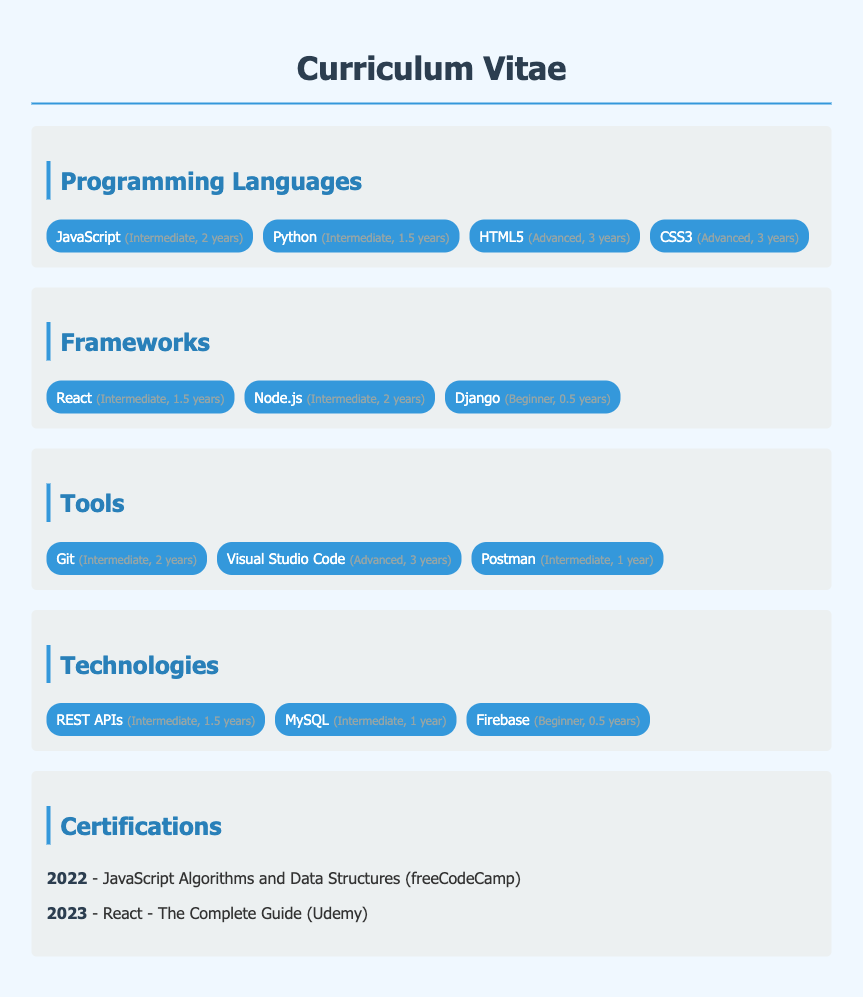what is the proficiency level of JavaScript? The proficiency level of JavaScript is listed as Intermediate with 2 years of experience.
Answer: Intermediate, 2 years how many programming languages are listed in the document? The document lists a total of four programming languages under the Programming Languages section.
Answer: 4 which framework has the highest proficiency level? The document does not mention a framework with a proficiency level higher than Intermediate; both React and Node.js have this level.
Answer: Intermediate when was the React certification obtained? The React certification is obtained in the year 2023 according to the Certifications section.
Answer: 2023 what is the total years of experience with tools mentioned? The tools listed indicate a total of 6 years of experience when adding up the individual experience years (3 + 2 + 1).
Answer: 6 years which technology has the least experience? The technology with the least experience mentioned is Firebase, with only 0.5 years.
Answer: Firebase, 0.5 years what is the title of the certification obtained in 2022? The title of the certification obtained in 2022 is JavaScript Algorithms and Data Structures.
Answer: JavaScript Algorithms and Data Structures how many years of experience does the document attribute to Visual Studio Code? Visual Studio Code has been noted with an Advanced proficiency level for 3 years of experience.
Answer: 3 years what is the color of the h1 header in the CV? The h1 header color is specified as #2c3e50 in the document.
Answer: #2c3e50 